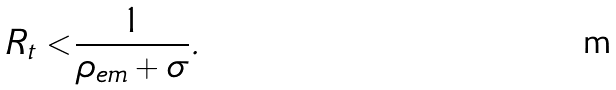<formula> <loc_0><loc_0><loc_500><loc_500>R _ { t } < \frac { 1 } { \rho _ { e m } + \sigma } .</formula> 